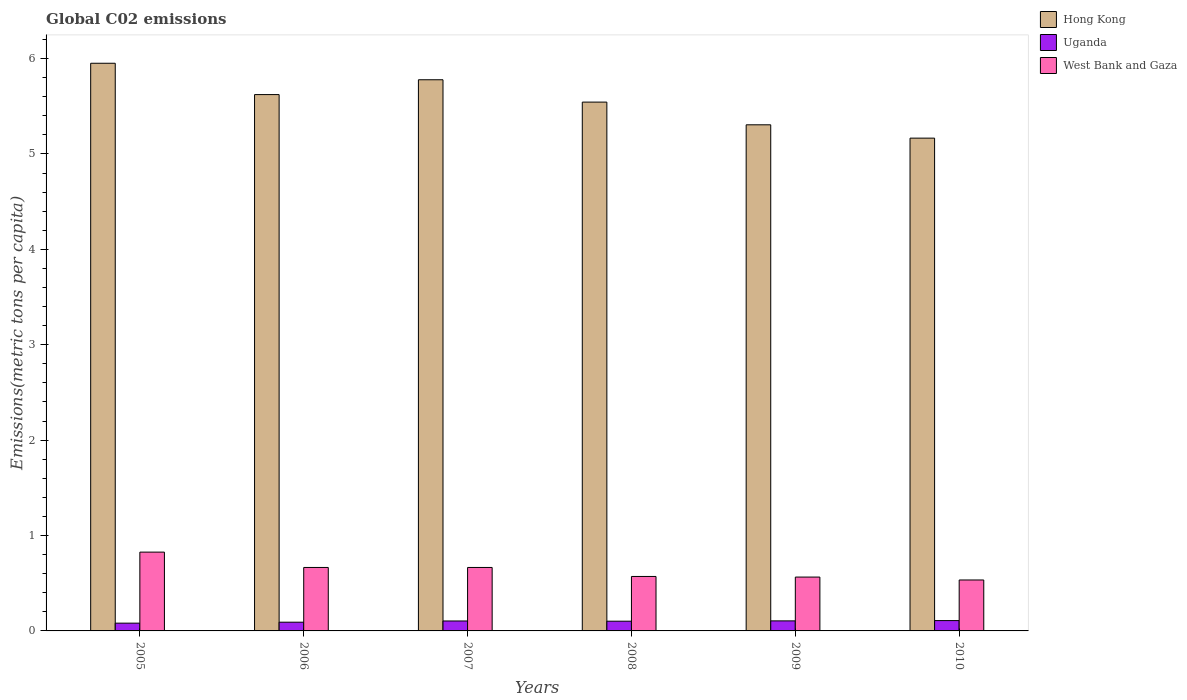How many different coloured bars are there?
Your response must be concise. 3. How many groups of bars are there?
Provide a short and direct response. 6. Are the number of bars on each tick of the X-axis equal?
Keep it short and to the point. Yes. How many bars are there on the 4th tick from the left?
Ensure brevity in your answer.  3. What is the label of the 5th group of bars from the left?
Ensure brevity in your answer.  2009. What is the amount of CO2 emitted in in Uganda in 2005?
Your answer should be very brief. 0.08. Across all years, what is the maximum amount of CO2 emitted in in Uganda?
Give a very brief answer. 0.11. Across all years, what is the minimum amount of CO2 emitted in in Uganda?
Your answer should be very brief. 0.08. In which year was the amount of CO2 emitted in in Hong Kong maximum?
Keep it short and to the point. 2005. In which year was the amount of CO2 emitted in in Hong Kong minimum?
Your response must be concise. 2010. What is the total amount of CO2 emitted in in Hong Kong in the graph?
Offer a very short reply. 33.37. What is the difference between the amount of CO2 emitted in in West Bank and Gaza in 2008 and that in 2010?
Your response must be concise. 0.04. What is the difference between the amount of CO2 emitted in in Uganda in 2008 and the amount of CO2 emitted in in Hong Kong in 2005?
Your answer should be compact. -5.85. What is the average amount of CO2 emitted in in Hong Kong per year?
Provide a short and direct response. 5.56. In the year 2009, what is the difference between the amount of CO2 emitted in in Hong Kong and amount of CO2 emitted in in Uganda?
Ensure brevity in your answer.  5.2. What is the ratio of the amount of CO2 emitted in in West Bank and Gaza in 2008 to that in 2010?
Your response must be concise. 1.07. Is the difference between the amount of CO2 emitted in in Hong Kong in 2005 and 2009 greater than the difference between the amount of CO2 emitted in in Uganda in 2005 and 2009?
Ensure brevity in your answer.  Yes. What is the difference between the highest and the second highest amount of CO2 emitted in in West Bank and Gaza?
Keep it short and to the point. 0.16. What is the difference between the highest and the lowest amount of CO2 emitted in in Hong Kong?
Your answer should be very brief. 0.78. Is the sum of the amount of CO2 emitted in in Hong Kong in 2005 and 2006 greater than the maximum amount of CO2 emitted in in Uganda across all years?
Make the answer very short. Yes. What does the 2nd bar from the left in 2008 represents?
Make the answer very short. Uganda. What does the 1st bar from the right in 2010 represents?
Provide a short and direct response. West Bank and Gaza. Is it the case that in every year, the sum of the amount of CO2 emitted in in Uganda and amount of CO2 emitted in in West Bank and Gaza is greater than the amount of CO2 emitted in in Hong Kong?
Provide a short and direct response. No. How many bars are there?
Give a very brief answer. 18. Are all the bars in the graph horizontal?
Offer a very short reply. No. How many years are there in the graph?
Keep it short and to the point. 6. Does the graph contain grids?
Keep it short and to the point. No. Where does the legend appear in the graph?
Give a very brief answer. Top right. How are the legend labels stacked?
Offer a very short reply. Vertical. What is the title of the graph?
Your answer should be very brief. Global C02 emissions. Does "Congo (Republic)" appear as one of the legend labels in the graph?
Your answer should be compact. No. What is the label or title of the Y-axis?
Keep it short and to the point. Emissions(metric tons per capita). What is the Emissions(metric tons per capita) in Hong Kong in 2005?
Your response must be concise. 5.95. What is the Emissions(metric tons per capita) in Uganda in 2005?
Provide a short and direct response. 0.08. What is the Emissions(metric tons per capita) in West Bank and Gaza in 2005?
Provide a short and direct response. 0.83. What is the Emissions(metric tons per capita) in Hong Kong in 2006?
Offer a terse response. 5.62. What is the Emissions(metric tons per capita) of Uganda in 2006?
Your response must be concise. 0.09. What is the Emissions(metric tons per capita) in West Bank and Gaza in 2006?
Offer a very short reply. 0.67. What is the Emissions(metric tons per capita) of Hong Kong in 2007?
Offer a very short reply. 5.78. What is the Emissions(metric tons per capita) in Uganda in 2007?
Your answer should be very brief. 0.1. What is the Emissions(metric tons per capita) of West Bank and Gaza in 2007?
Make the answer very short. 0.67. What is the Emissions(metric tons per capita) of Hong Kong in 2008?
Your answer should be compact. 5.54. What is the Emissions(metric tons per capita) of Uganda in 2008?
Your answer should be very brief. 0.1. What is the Emissions(metric tons per capita) in West Bank and Gaza in 2008?
Your answer should be very brief. 0.57. What is the Emissions(metric tons per capita) of Hong Kong in 2009?
Your answer should be compact. 5.31. What is the Emissions(metric tons per capita) in Uganda in 2009?
Make the answer very short. 0.11. What is the Emissions(metric tons per capita) in West Bank and Gaza in 2009?
Keep it short and to the point. 0.56. What is the Emissions(metric tons per capita) of Hong Kong in 2010?
Provide a short and direct response. 5.17. What is the Emissions(metric tons per capita) in Uganda in 2010?
Ensure brevity in your answer.  0.11. What is the Emissions(metric tons per capita) in West Bank and Gaza in 2010?
Ensure brevity in your answer.  0.53. Across all years, what is the maximum Emissions(metric tons per capita) in Hong Kong?
Provide a succinct answer. 5.95. Across all years, what is the maximum Emissions(metric tons per capita) of Uganda?
Provide a succinct answer. 0.11. Across all years, what is the maximum Emissions(metric tons per capita) of West Bank and Gaza?
Keep it short and to the point. 0.83. Across all years, what is the minimum Emissions(metric tons per capita) of Hong Kong?
Make the answer very short. 5.17. Across all years, what is the minimum Emissions(metric tons per capita) of Uganda?
Make the answer very short. 0.08. Across all years, what is the minimum Emissions(metric tons per capita) in West Bank and Gaza?
Your response must be concise. 0.53. What is the total Emissions(metric tons per capita) of Hong Kong in the graph?
Your answer should be compact. 33.37. What is the total Emissions(metric tons per capita) in Uganda in the graph?
Offer a terse response. 0.59. What is the total Emissions(metric tons per capita) of West Bank and Gaza in the graph?
Your answer should be compact. 3.83. What is the difference between the Emissions(metric tons per capita) in Hong Kong in 2005 and that in 2006?
Offer a very short reply. 0.33. What is the difference between the Emissions(metric tons per capita) in Uganda in 2005 and that in 2006?
Ensure brevity in your answer.  -0.01. What is the difference between the Emissions(metric tons per capita) in West Bank and Gaza in 2005 and that in 2006?
Keep it short and to the point. 0.16. What is the difference between the Emissions(metric tons per capita) of Hong Kong in 2005 and that in 2007?
Provide a short and direct response. 0.17. What is the difference between the Emissions(metric tons per capita) of Uganda in 2005 and that in 2007?
Provide a short and direct response. -0.02. What is the difference between the Emissions(metric tons per capita) of West Bank and Gaza in 2005 and that in 2007?
Provide a short and direct response. 0.16. What is the difference between the Emissions(metric tons per capita) in Hong Kong in 2005 and that in 2008?
Make the answer very short. 0.41. What is the difference between the Emissions(metric tons per capita) in Uganda in 2005 and that in 2008?
Offer a terse response. -0.02. What is the difference between the Emissions(metric tons per capita) in West Bank and Gaza in 2005 and that in 2008?
Your response must be concise. 0.26. What is the difference between the Emissions(metric tons per capita) of Hong Kong in 2005 and that in 2009?
Give a very brief answer. 0.65. What is the difference between the Emissions(metric tons per capita) in Uganda in 2005 and that in 2009?
Make the answer very short. -0.02. What is the difference between the Emissions(metric tons per capita) in West Bank and Gaza in 2005 and that in 2009?
Make the answer very short. 0.26. What is the difference between the Emissions(metric tons per capita) in Hong Kong in 2005 and that in 2010?
Provide a short and direct response. 0.78. What is the difference between the Emissions(metric tons per capita) of Uganda in 2005 and that in 2010?
Give a very brief answer. -0.03. What is the difference between the Emissions(metric tons per capita) of West Bank and Gaza in 2005 and that in 2010?
Offer a very short reply. 0.29. What is the difference between the Emissions(metric tons per capita) of Hong Kong in 2006 and that in 2007?
Give a very brief answer. -0.16. What is the difference between the Emissions(metric tons per capita) of Uganda in 2006 and that in 2007?
Your answer should be compact. -0.01. What is the difference between the Emissions(metric tons per capita) in Hong Kong in 2006 and that in 2008?
Provide a short and direct response. 0.08. What is the difference between the Emissions(metric tons per capita) of Uganda in 2006 and that in 2008?
Keep it short and to the point. -0.01. What is the difference between the Emissions(metric tons per capita) of West Bank and Gaza in 2006 and that in 2008?
Make the answer very short. 0.09. What is the difference between the Emissions(metric tons per capita) in Hong Kong in 2006 and that in 2009?
Provide a short and direct response. 0.32. What is the difference between the Emissions(metric tons per capita) of Uganda in 2006 and that in 2009?
Your answer should be very brief. -0.01. What is the difference between the Emissions(metric tons per capita) of West Bank and Gaza in 2006 and that in 2009?
Make the answer very short. 0.1. What is the difference between the Emissions(metric tons per capita) of Hong Kong in 2006 and that in 2010?
Provide a succinct answer. 0.46. What is the difference between the Emissions(metric tons per capita) in Uganda in 2006 and that in 2010?
Provide a succinct answer. -0.02. What is the difference between the Emissions(metric tons per capita) of West Bank and Gaza in 2006 and that in 2010?
Make the answer very short. 0.13. What is the difference between the Emissions(metric tons per capita) in Hong Kong in 2007 and that in 2008?
Provide a succinct answer. 0.23. What is the difference between the Emissions(metric tons per capita) in Uganda in 2007 and that in 2008?
Ensure brevity in your answer.  0. What is the difference between the Emissions(metric tons per capita) of West Bank and Gaza in 2007 and that in 2008?
Your answer should be compact. 0.09. What is the difference between the Emissions(metric tons per capita) in Hong Kong in 2007 and that in 2009?
Your response must be concise. 0.47. What is the difference between the Emissions(metric tons per capita) of Uganda in 2007 and that in 2009?
Provide a succinct answer. -0. What is the difference between the Emissions(metric tons per capita) in West Bank and Gaza in 2007 and that in 2009?
Offer a terse response. 0.1. What is the difference between the Emissions(metric tons per capita) of Hong Kong in 2007 and that in 2010?
Give a very brief answer. 0.61. What is the difference between the Emissions(metric tons per capita) in Uganda in 2007 and that in 2010?
Your answer should be compact. -0. What is the difference between the Emissions(metric tons per capita) of West Bank and Gaza in 2007 and that in 2010?
Offer a very short reply. 0.13. What is the difference between the Emissions(metric tons per capita) in Hong Kong in 2008 and that in 2009?
Your answer should be very brief. 0.24. What is the difference between the Emissions(metric tons per capita) in Uganda in 2008 and that in 2009?
Your answer should be very brief. -0. What is the difference between the Emissions(metric tons per capita) in West Bank and Gaza in 2008 and that in 2009?
Your response must be concise. 0.01. What is the difference between the Emissions(metric tons per capita) of Hong Kong in 2008 and that in 2010?
Ensure brevity in your answer.  0.38. What is the difference between the Emissions(metric tons per capita) in Uganda in 2008 and that in 2010?
Offer a very short reply. -0.01. What is the difference between the Emissions(metric tons per capita) of West Bank and Gaza in 2008 and that in 2010?
Offer a terse response. 0.04. What is the difference between the Emissions(metric tons per capita) of Hong Kong in 2009 and that in 2010?
Your answer should be compact. 0.14. What is the difference between the Emissions(metric tons per capita) of Uganda in 2009 and that in 2010?
Offer a terse response. -0. What is the difference between the Emissions(metric tons per capita) in West Bank and Gaza in 2009 and that in 2010?
Provide a succinct answer. 0.03. What is the difference between the Emissions(metric tons per capita) of Hong Kong in 2005 and the Emissions(metric tons per capita) of Uganda in 2006?
Keep it short and to the point. 5.86. What is the difference between the Emissions(metric tons per capita) of Hong Kong in 2005 and the Emissions(metric tons per capita) of West Bank and Gaza in 2006?
Give a very brief answer. 5.29. What is the difference between the Emissions(metric tons per capita) of Uganda in 2005 and the Emissions(metric tons per capita) of West Bank and Gaza in 2006?
Your answer should be compact. -0.58. What is the difference between the Emissions(metric tons per capita) of Hong Kong in 2005 and the Emissions(metric tons per capita) of Uganda in 2007?
Ensure brevity in your answer.  5.85. What is the difference between the Emissions(metric tons per capita) in Hong Kong in 2005 and the Emissions(metric tons per capita) in West Bank and Gaza in 2007?
Ensure brevity in your answer.  5.29. What is the difference between the Emissions(metric tons per capita) in Uganda in 2005 and the Emissions(metric tons per capita) in West Bank and Gaza in 2007?
Make the answer very short. -0.58. What is the difference between the Emissions(metric tons per capita) in Hong Kong in 2005 and the Emissions(metric tons per capita) in Uganda in 2008?
Your answer should be compact. 5.85. What is the difference between the Emissions(metric tons per capita) in Hong Kong in 2005 and the Emissions(metric tons per capita) in West Bank and Gaza in 2008?
Make the answer very short. 5.38. What is the difference between the Emissions(metric tons per capita) in Uganda in 2005 and the Emissions(metric tons per capita) in West Bank and Gaza in 2008?
Your response must be concise. -0.49. What is the difference between the Emissions(metric tons per capita) in Hong Kong in 2005 and the Emissions(metric tons per capita) in Uganda in 2009?
Offer a very short reply. 5.85. What is the difference between the Emissions(metric tons per capita) in Hong Kong in 2005 and the Emissions(metric tons per capita) in West Bank and Gaza in 2009?
Offer a terse response. 5.39. What is the difference between the Emissions(metric tons per capita) of Uganda in 2005 and the Emissions(metric tons per capita) of West Bank and Gaza in 2009?
Keep it short and to the point. -0.48. What is the difference between the Emissions(metric tons per capita) of Hong Kong in 2005 and the Emissions(metric tons per capita) of Uganda in 2010?
Make the answer very short. 5.84. What is the difference between the Emissions(metric tons per capita) in Hong Kong in 2005 and the Emissions(metric tons per capita) in West Bank and Gaza in 2010?
Offer a terse response. 5.42. What is the difference between the Emissions(metric tons per capita) in Uganda in 2005 and the Emissions(metric tons per capita) in West Bank and Gaza in 2010?
Keep it short and to the point. -0.45. What is the difference between the Emissions(metric tons per capita) in Hong Kong in 2006 and the Emissions(metric tons per capita) in Uganda in 2007?
Offer a terse response. 5.52. What is the difference between the Emissions(metric tons per capita) of Hong Kong in 2006 and the Emissions(metric tons per capita) of West Bank and Gaza in 2007?
Ensure brevity in your answer.  4.96. What is the difference between the Emissions(metric tons per capita) of Uganda in 2006 and the Emissions(metric tons per capita) of West Bank and Gaza in 2007?
Make the answer very short. -0.57. What is the difference between the Emissions(metric tons per capita) in Hong Kong in 2006 and the Emissions(metric tons per capita) in Uganda in 2008?
Offer a very short reply. 5.52. What is the difference between the Emissions(metric tons per capita) of Hong Kong in 2006 and the Emissions(metric tons per capita) of West Bank and Gaza in 2008?
Keep it short and to the point. 5.05. What is the difference between the Emissions(metric tons per capita) of Uganda in 2006 and the Emissions(metric tons per capita) of West Bank and Gaza in 2008?
Your answer should be compact. -0.48. What is the difference between the Emissions(metric tons per capita) in Hong Kong in 2006 and the Emissions(metric tons per capita) in Uganda in 2009?
Your answer should be very brief. 5.52. What is the difference between the Emissions(metric tons per capita) of Hong Kong in 2006 and the Emissions(metric tons per capita) of West Bank and Gaza in 2009?
Offer a very short reply. 5.06. What is the difference between the Emissions(metric tons per capita) of Uganda in 2006 and the Emissions(metric tons per capita) of West Bank and Gaza in 2009?
Keep it short and to the point. -0.47. What is the difference between the Emissions(metric tons per capita) in Hong Kong in 2006 and the Emissions(metric tons per capita) in Uganda in 2010?
Keep it short and to the point. 5.51. What is the difference between the Emissions(metric tons per capita) of Hong Kong in 2006 and the Emissions(metric tons per capita) of West Bank and Gaza in 2010?
Provide a short and direct response. 5.09. What is the difference between the Emissions(metric tons per capita) of Uganda in 2006 and the Emissions(metric tons per capita) of West Bank and Gaza in 2010?
Keep it short and to the point. -0.44. What is the difference between the Emissions(metric tons per capita) of Hong Kong in 2007 and the Emissions(metric tons per capita) of Uganda in 2008?
Provide a succinct answer. 5.68. What is the difference between the Emissions(metric tons per capita) of Hong Kong in 2007 and the Emissions(metric tons per capita) of West Bank and Gaza in 2008?
Ensure brevity in your answer.  5.21. What is the difference between the Emissions(metric tons per capita) of Uganda in 2007 and the Emissions(metric tons per capita) of West Bank and Gaza in 2008?
Your response must be concise. -0.47. What is the difference between the Emissions(metric tons per capita) of Hong Kong in 2007 and the Emissions(metric tons per capita) of Uganda in 2009?
Give a very brief answer. 5.67. What is the difference between the Emissions(metric tons per capita) of Hong Kong in 2007 and the Emissions(metric tons per capita) of West Bank and Gaza in 2009?
Your response must be concise. 5.21. What is the difference between the Emissions(metric tons per capita) of Uganda in 2007 and the Emissions(metric tons per capita) of West Bank and Gaza in 2009?
Give a very brief answer. -0.46. What is the difference between the Emissions(metric tons per capita) in Hong Kong in 2007 and the Emissions(metric tons per capita) in Uganda in 2010?
Your answer should be compact. 5.67. What is the difference between the Emissions(metric tons per capita) of Hong Kong in 2007 and the Emissions(metric tons per capita) of West Bank and Gaza in 2010?
Provide a short and direct response. 5.24. What is the difference between the Emissions(metric tons per capita) in Uganda in 2007 and the Emissions(metric tons per capita) in West Bank and Gaza in 2010?
Your response must be concise. -0.43. What is the difference between the Emissions(metric tons per capita) in Hong Kong in 2008 and the Emissions(metric tons per capita) in Uganda in 2009?
Your answer should be very brief. 5.44. What is the difference between the Emissions(metric tons per capita) in Hong Kong in 2008 and the Emissions(metric tons per capita) in West Bank and Gaza in 2009?
Provide a succinct answer. 4.98. What is the difference between the Emissions(metric tons per capita) in Uganda in 2008 and the Emissions(metric tons per capita) in West Bank and Gaza in 2009?
Keep it short and to the point. -0.46. What is the difference between the Emissions(metric tons per capita) in Hong Kong in 2008 and the Emissions(metric tons per capita) in Uganda in 2010?
Offer a terse response. 5.44. What is the difference between the Emissions(metric tons per capita) in Hong Kong in 2008 and the Emissions(metric tons per capita) in West Bank and Gaza in 2010?
Keep it short and to the point. 5.01. What is the difference between the Emissions(metric tons per capita) of Uganda in 2008 and the Emissions(metric tons per capita) of West Bank and Gaza in 2010?
Keep it short and to the point. -0.43. What is the difference between the Emissions(metric tons per capita) of Hong Kong in 2009 and the Emissions(metric tons per capita) of Uganda in 2010?
Keep it short and to the point. 5.2. What is the difference between the Emissions(metric tons per capita) in Hong Kong in 2009 and the Emissions(metric tons per capita) in West Bank and Gaza in 2010?
Give a very brief answer. 4.77. What is the difference between the Emissions(metric tons per capita) in Uganda in 2009 and the Emissions(metric tons per capita) in West Bank and Gaza in 2010?
Your answer should be compact. -0.43. What is the average Emissions(metric tons per capita) of Hong Kong per year?
Give a very brief answer. 5.56. What is the average Emissions(metric tons per capita) in Uganda per year?
Your answer should be very brief. 0.1. What is the average Emissions(metric tons per capita) of West Bank and Gaza per year?
Your response must be concise. 0.64. In the year 2005, what is the difference between the Emissions(metric tons per capita) of Hong Kong and Emissions(metric tons per capita) of Uganda?
Provide a succinct answer. 5.87. In the year 2005, what is the difference between the Emissions(metric tons per capita) in Hong Kong and Emissions(metric tons per capita) in West Bank and Gaza?
Keep it short and to the point. 5.12. In the year 2005, what is the difference between the Emissions(metric tons per capita) of Uganda and Emissions(metric tons per capita) of West Bank and Gaza?
Offer a very short reply. -0.74. In the year 2006, what is the difference between the Emissions(metric tons per capita) of Hong Kong and Emissions(metric tons per capita) of Uganda?
Provide a succinct answer. 5.53. In the year 2006, what is the difference between the Emissions(metric tons per capita) of Hong Kong and Emissions(metric tons per capita) of West Bank and Gaza?
Provide a short and direct response. 4.96. In the year 2006, what is the difference between the Emissions(metric tons per capita) of Uganda and Emissions(metric tons per capita) of West Bank and Gaza?
Ensure brevity in your answer.  -0.57. In the year 2007, what is the difference between the Emissions(metric tons per capita) of Hong Kong and Emissions(metric tons per capita) of Uganda?
Keep it short and to the point. 5.67. In the year 2007, what is the difference between the Emissions(metric tons per capita) in Hong Kong and Emissions(metric tons per capita) in West Bank and Gaza?
Your answer should be very brief. 5.11. In the year 2007, what is the difference between the Emissions(metric tons per capita) of Uganda and Emissions(metric tons per capita) of West Bank and Gaza?
Offer a terse response. -0.56. In the year 2008, what is the difference between the Emissions(metric tons per capita) of Hong Kong and Emissions(metric tons per capita) of Uganda?
Offer a very short reply. 5.44. In the year 2008, what is the difference between the Emissions(metric tons per capita) in Hong Kong and Emissions(metric tons per capita) in West Bank and Gaza?
Provide a succinct answer. 4.97. In the year 2008, what is the difference between the Emissions(metric tons per capita) in Uganda and Emissions(metric tons per capita) in West Bank and Gaza?
Your response must be concise. -0.47. In the year 2009, what is the difference between the Emissions(metric tons per capita) in Hong Kong and Emissions(metric tons per capita) in Uganda?
Offer a terse response. 5.2. In the year 2009, what is the difference between the Emissions(metric tons per capita) in Hong Kong and Emissions(metric tons per capita) in West Bank and Gaza?
Keep it short and to the point. 4.74. In the year 2009, what is the difference between the Emissions(metric tons per capita) of Uganda and Emissions(metric tons per capita) of West Bank and Gaza?
Your response must be concise. -0.46. In the year 2010, what is the difference between the Emissions(metric tons per capita) in Hong Kong and Emissions(metric tons per capita) in Uganda?
Your answer should be very brief. 5.06. In the year 2010, what is the difference between the Emissions(metric tons per capita) in Hong Kong and Emissions(metric tons per capita) in West Bank and Gaza?
Your answer should be compact. 4.63. In the year 2010, what is the difference between the Emissions(metric tons per capita) of Uganda and Emissions(metric tons per capita) of West Bank and Gaza?
Your answer should be very brief. -0.43. What is the ratio of the Emissions(metric tons per capita) of Hong Kong in 2005 to that in 2006?
Keep it short and to the point. 1.06. What is the ratio of the Emissions(metric tons per capita) in Uganda in 2005 to that in 2006?
Provide a succinct answer. 0.89. What is the ratio of the Emissions(metric tons per capita) of West Bank and Gaza in 2005 to that in 2006?
Provide a short and direct response. 1.24. What is the ratio of the Emissions(metric tons per capita) of Hong Kong in 2005 to that in 2007?
Your response must be concise. 1.03. What is the ratio of the Emissions(metric tons per capita) of Uganda in 2005 to that in 2007?
Offer a terse response. 0.78. What is the ratio of the Emissions(metric tons per capita) of West Bank and Gaza in 2005 to that in 2007?
Provide a succinct answer. 1.24. What is the ratio of the Emissions(metric tons per capita) in Hong Kong in 2005 to that in 2008?
Your answer should be very brief. 1.07. What is the ratio of the Emissions(metric tons per capita) in Uganda in 2005 to that in 2008?
Your answer should be very brief. 0.8. What is the ratio of the Emissions(metric tons per capita) of West Bank and Gaza in 2005 to that in 2008?
Give a very brief answer. 1.45. What is the ratio of the Emissions(metric tons per capita) of Hong Kong in 2005 to that in 2009?
Offer a very short reply. 1.12. What is the ratio of the Emissions(metric tons per capita) of Uganda in 2005 to that in 2009?
Your answer should be very brief. 0.77. What is the ratio of the Emissions(metric tons per capita) in West Bank and Gaza in 2005 to that in 2009?
Keep it short and to the point. 1.46. What is the ratio of the Emissions(metric tons per capita) of Hong Kong in 2005 to that in 2010?
Offer a very short reply. 1.15. What is the ratio of the Emissions(metric tons per capita) in Uganda in 2005 to that in 2010?
Keep it short and to the point. 0.75. What is the ratio of the Emissions(metric tons per capita) in West Bank and Gaza in 2005 to that in 2010?
Ensure brevity in your answer.  1.55. What is the ratio of the Emissions(metric tons per capita) of Hong Kong in 2006 to that in 2007?
Offer a very short reply. 0.97. What is the ratio of the Emissions(metric tons per capita) of Uganda in 2006 to that in 2007?
Offer a terse response. 0.88. What is the ratio of the Emissions(metric tons per capita) in West Bank and Gaza in 2006 to that in 2007?
Offer a terse response. 1. What is the ratio of the Emissions(metric tons per capita) in Hong Kong in 2006 to that in 2008?
Your answer should be very brief. 1.01. What is the ratio of the Emissions(metric tons per capita) of Uganda in 2006 to that in 2008?
Your answer should be very brief. 0.9. What is the ratio of the Emissions(metric tons per capita) in West Bank and Gaza in 2006 to that in 2008?
Your answer should be very brief. 1.17. What is the ratio of the Emissions(metric tons per capita) in Hong Kong in 2006 to that in 2009?
Make the answer very short. 1.06. What is the ratio of the Emissions(metric tons per capita) in Uganda in 2006 to that in 2009?
Your answer should be very brief. 0.87. What is the ratio of the Emissions(metric tons per capita) of West Bank and Gaza in 2006 to that in 2009?
Provide a short and direct response. 1.18. What is the ratio of the Emissions(metric tons per capita) in Hong Kong in 2006 to that in 2010?
Provide a short and direct response. 1.09. What is the ratio of the Emissions(metric tons per capita) of Uganda in 2006 to that in 2010?
Your response must be concise. 0.85. What is the ratio of the Emissions(metric tons per capita) in West Bank and Gaza in 2006 to that in 2010?
Your response must be concise. 1.25. What is the ratio of the Emissions(metric tons per capita) of Hong Kong in 2007 to that in 2008?
Make the answer very short. 1.04. What is the ratio of the Emissions(metric tons per capita) in Uganda in 2007 to that in 2008?
Your answer should be compact. 1.02. What is the ratio of the Emissions(metric tons per capita) of West Bank and Gaza in 2007 to that in 2008?
Your answer should be compact. 1.17. What is the ratio of the Emissions(metric tons per capita) in Hong Kong in 2007 to that in 2009?
Offer a terse response. 1.09. What is the ratio of the Emissions(metric tons per capita) of Uganda in 2007 to that in 2009?
Offer a very short reply. 0.99. What is the ratio of the Emissions(metric tons per capita) of West Bank and Gaza in 2007 to that in 2009?
Make the answer very short. 1.18. What is the ratio of the Emissions(metric tons per capita) in Hong Kong in 2007 to that in 2010?
Provide a succinct answer. 1.12. What is the ratio of the Emissions(metric tons per capita) of Uganda in 2007 to that in 2010?
Give a very brief answer. 0.96. What is the ratio of the Emissions(metric tons per capita) of West Bank and Gaza in 2007 to that in 2010?
Your answer should be compact. 1.25. What is the ratio of the Emissions(metric tons per capita) of Hong Kong in 2008 to that in 2009?
Ensure brevity in your answer.  1.04. What is the ratio of the Emissions(metric tons per capita) of Uganda in 2008 to that in 2009?
Offer a very short reply. 0.97. What is the ratio of the Emissions(metric tons per capita) of West Bank and Gaza in 2008 to that in 2009?
Make the answer very short. 1.01. What is the ratio of the Emissions(metric tons per capita) of Hong Kong in 2008 to that in 2010?
Your answer should be very brief. 1.07. What is the ratio of the Emissions(metric tons per capita) of Uganda in 2008 to that in 2010?
Provide a succinct answer. 0.94. What is the ratio of the Emissions(metric tons per capita) in West Bank and Gaza in 2008 to that in 2010?
Ensure brevity in your answer.  1.07. What is the ratio of the Emissions(metric tons per capita) of Uganda in 2009 to that in 2010?
Keep it short and to the point. 0.97. What is the ratio of the Emissions(metric tons per capita) of West Bank and Gaza in 2009 to that in 2010?
Give a very brief answer. 1.06. What is the difference between the highest and the second highest Emissions(metric tons per capita) in Hong Kong?
Offer a terse response. 0.17. What is the difference between the highest and the second highest Emissions(metric tons per capita) in Uganda?
Offer a very short reply. 0. What is the difference between the highest and the second highest Emissions(metric tons per capita) of West Bank and Gaza?
Give a very brief answer. 0.16. What is the difference between the highest and the lowest Emissions(metric tons per capita) in Hong Kong?
Keep it short and to the point. 0.78. What is the difference between the highest and the lowest Emissions(metric tons per capita) of Uganda?
Your response must be concise. 0.03. What is the difference between the highest and the lowest Emissions(metric tons per capita) in West Bank and Gaza?
Provide a succinct answer. 0.29. 